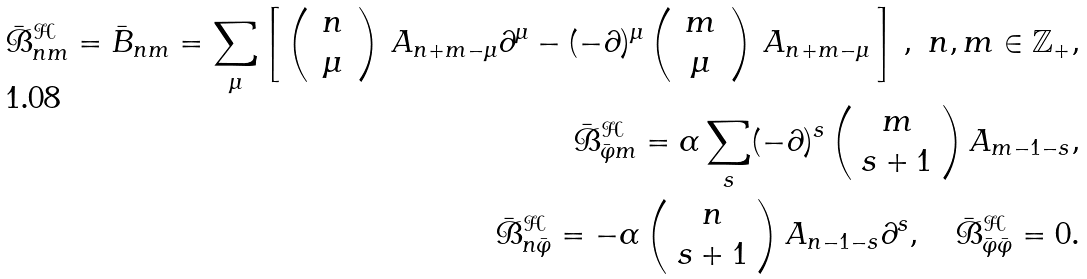<formula> <loc_0><loc_0><loc_500><loc_500>\bar { \mathcal { B } } ^ { \mathcal { H } } _ { n m } = \bar { B } _ { n m } = \sum _ { \mu } \left [ \, \left ( \, \begin{array} { c } n \\ \mu \end{array} \, \right ) \, A _ { n + m - \mu } \partial ^ { \mu } - ( - \partial ) ^ { \mu } \left ( \, \begin{array} { c } m \\ \mu \end{array} \, \right ) \, A _ { n + m - \mu } \, \right ] \, , \ n , m \in { \mathbb { Z } } _ { + } , \\ \bar { \mathcal { B } } ^ { \mathcal { H } } _ { \bar { \varphi } m } = \alpha \sum _ { s } ( - \partial ) ^ { s } \left ( \begin{array} { c } m \\ s + 1 \end{array} \right ) A _ { m - 1 - s } , \\ \bar { \mathcal { B } } ^ { \mathcal { H } } _ { n \bar { \varphi } } = - \alpha \left ( \begin{array} { c } n \\ s + 1 \end{array} \right ) A _ { n - 1 - s } \partial ^ { s } , \quad \bar { \mathcal { B } } ^ { \mathcal { H } } _ { \bar { \varphi } \bar { \varphi } } = 0 .</formula> 